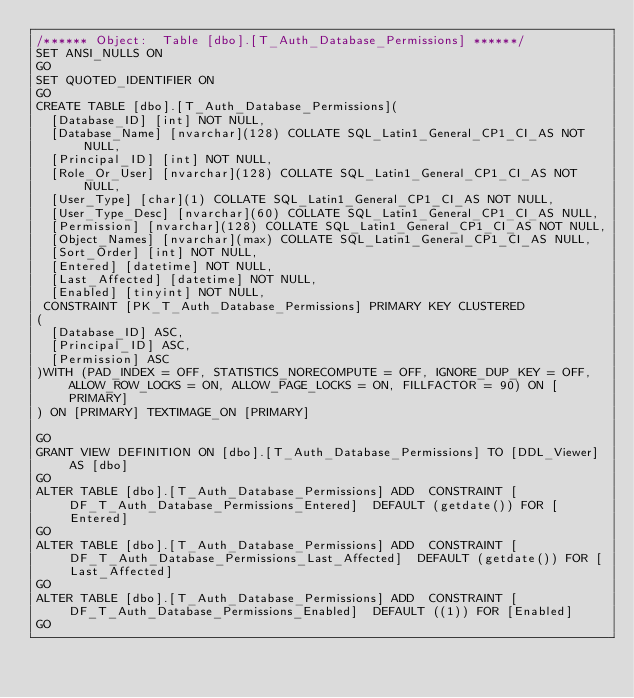<code> <loc_0><loc_0><loc_500><loc_500><_SQL_>/****** Object:  Table [dbo].[T_Auth_Database_Permissions] ******/
SET ANSI_NULLS ON
GO
SET QUOTED_IDENTIFIER ON
GO
CREATE TABLE [dbo].[T_Auth_Database_Permissions](
	[Database_ID] [int] NOT NULL,
	[Database_Name] [nvarchar](128) COLLATE SQL_Latin1_General_CP1_CI_AS NOT NULL,
	[Principal_ID] [int] NOT NULL,
	[Role_Or_User] [nvarchar](128) COLLATE SQL_Latin1_General_CP1_CI_AS NOT NULL,
	[User_Type] [char](1) COLLATE SQL_Latin1_General_CP1_CI_AS NOT NULL,
	[User_Type_Desc] [nvarchar](60) COLLATE SQL_Latin1_General_CP1_CI_AS NULL,
	[Permission] [nvarchar](128) COLLATE SQL_Latin1_General_CP1_CI_AS NOT NULL,
	[Object_Names] [nvarchar](max) COLLATE SQL_Latin1_General_CP1_CI_AS NULL,
	[Sort_Order] [int] NOT NULL,
	[Entered] [datetime] NOT NULL,
	[Last_Affected] [datetime] NOT NULL,
	[Enabled] [tinyint] NOT NULL,
 CONSTRAINT [PK_T_Auth_Database_Permissions] PRIMARY KEY CLUSTERED 
(
	[Database_ID] ASC,
	[Principal_ID] ASC,
	[Permission] ASC
)WITH (PAD_INDEX = OFF, STATISTICS_NORECOMPUTE = OFF, IGNORE_DUP_KEY = OFF, ALLOW_ROW_LOCKS = ON, ALLOW_PAGE_LOCKS = ON, FILLFACTOR = 90) ON [PRIMARY]
) ON [PRIMARY] TEXTIMAGE_ON [PRIMARY]

GO
GRANT VIEW DEFINITION ON [dbo].[T_Auth_Database_Permissions] TO [DDL_Viewer] AS [dbo]
GO
ALTER TABLE [dbo].[T_Auth_Database_Permissions] ADD  CONSTRAINT [DF_T_Auth_Database_Permissions_Entered]  DEFAULT (getdate()) FOR [Entered]
GO
ALTER TABLE [dbo].[T_Auth_Database_Permissions] ADD  CONSTRAINT [DF_T_Auth_Database_Permissions_Last_Affected]  DEFAULT (getdate()) FOR [Last_Affected]
GO
ALTER TABLE [dbo].[T_Auth_Database_Permissions] ADD  CONSTRAINT [DF_T_Auth_Database_Permissions_Enabled]  DEFAULT ((1)) FOR [Enabled]
GO
</code> 